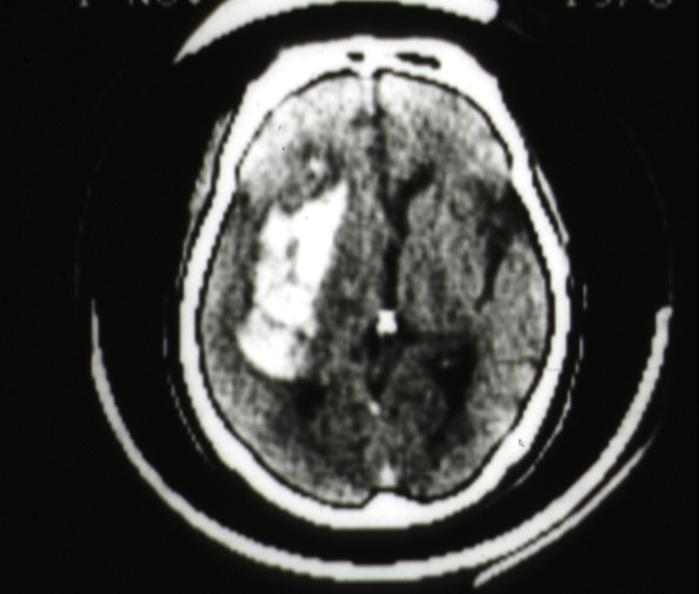what scan hemorrhage in putamen area?
Answer the question using a single word or phrase. Cat 